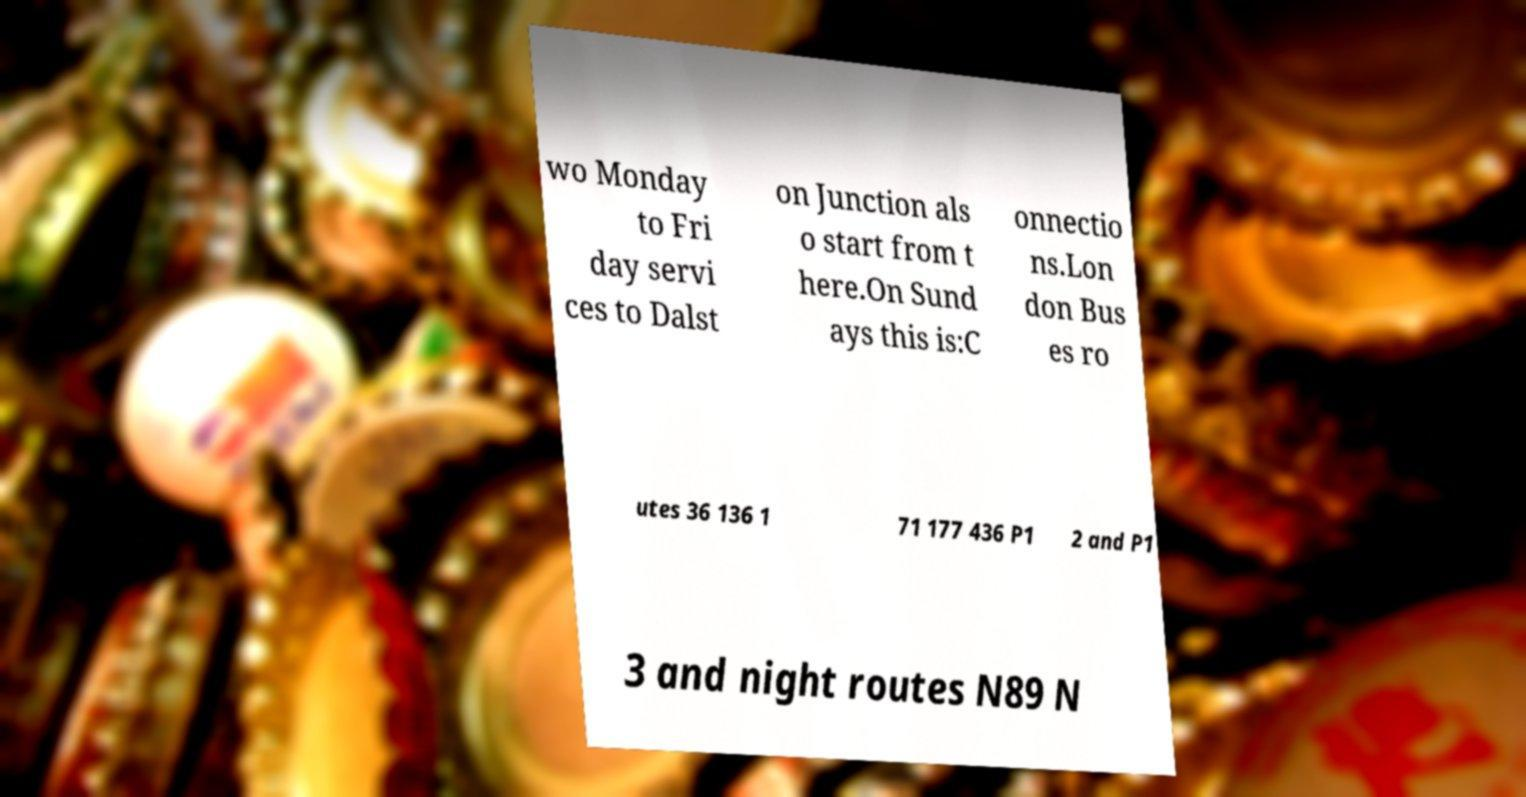For documentation purposes, I need the text within this image transcribed. Could you provide that? wo Monday to Fri day servi ces to Dalst on Junction als o start from t here.On Sund ays this is:C onnectio ns.Lon don Bus es ro utes 36 136 1 71 177 436 P1 2 and P1 3 and night routes N89 N 